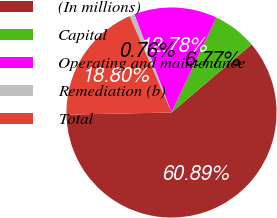<chart> <loc_0><loc_0><loc_500><loc_500><pie_chart><fcel>(In millions)<fcel>Capital<fcel>Operating and maintenance<fcel>Remediation (b)<fcel>Total<nl><fcel>60.89%<fcel>6.77%<fcel>12.78%<fcel>0.76%<fcel>18.8%<nl></chart> 